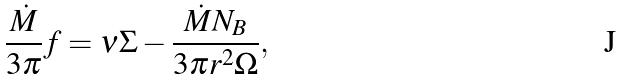Convert formula to latex. <formula><loc_0><loc_0><loc_500><loc_500>\frac { \dot { M } } { 3 \pi } f = \nu \Sigma - \frac { \dot { M } N _ { B } } { 3 \pi r ^ { 2 } \Omega } ,</formula> 